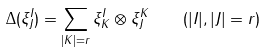Convert formula to latex. <formula><loc_0><loc_0><loc_500><loc_500>\Delta ( \xi ^ { I } _ { J } ) = \sum _ { | K | = r } \xi ^ { I } _ { K } \otimes \xi ^ { K } _ { J } \quad ( | I | , | J | = r )</formula> 